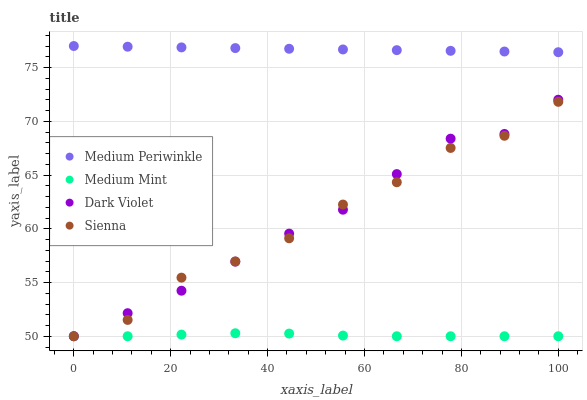Does Medium Mint have the minimum area under the curve?
Answer yes or no. Yes. Does Medium Periwinkle have the maximum area under the curve?
Answer yes or no. Yes. Does Sienna have the minimum area under the curve?
Answer yes or no. No. Does Sienna have the maximum area under the curve?
Answer yes or no. No. Is Medium Periwinkle the smoothest?
Answer yes or no. Yes. Is Sienna the roughest?
Answer yes or no. Yes. Is Sienna the smoothest?
Answer yes or no. No. Is Medium Periwinkle the roughest?
Answer yes or no. No. Does Medium Mint have the lowest value?
Answer yes or no. Yes. Does Medium Periwinkle have the lowest value?
Answer yes or no. No. Does Medium Periwinkle have the highest value?
Answer yes or no. Yes. Does Sienna have the highest value?
Answer yes or no. No. Is Sienna less than Medium Periwinkle?
Answer yes or no. Yes. Is Medium Periwinkle greater than Dark Violet?
Answer yes or no. Yes. Does Sienna intersect Medium Mint?
Answer yes or no. Yes. Is Sienna less than Medium Mint?
Answer yes or no. No. Is Sienna greater than Medium Mint?
Answer yes or no. No. Does Sienna intersect Medium Periwinkle?
Answer yes or no. No. 